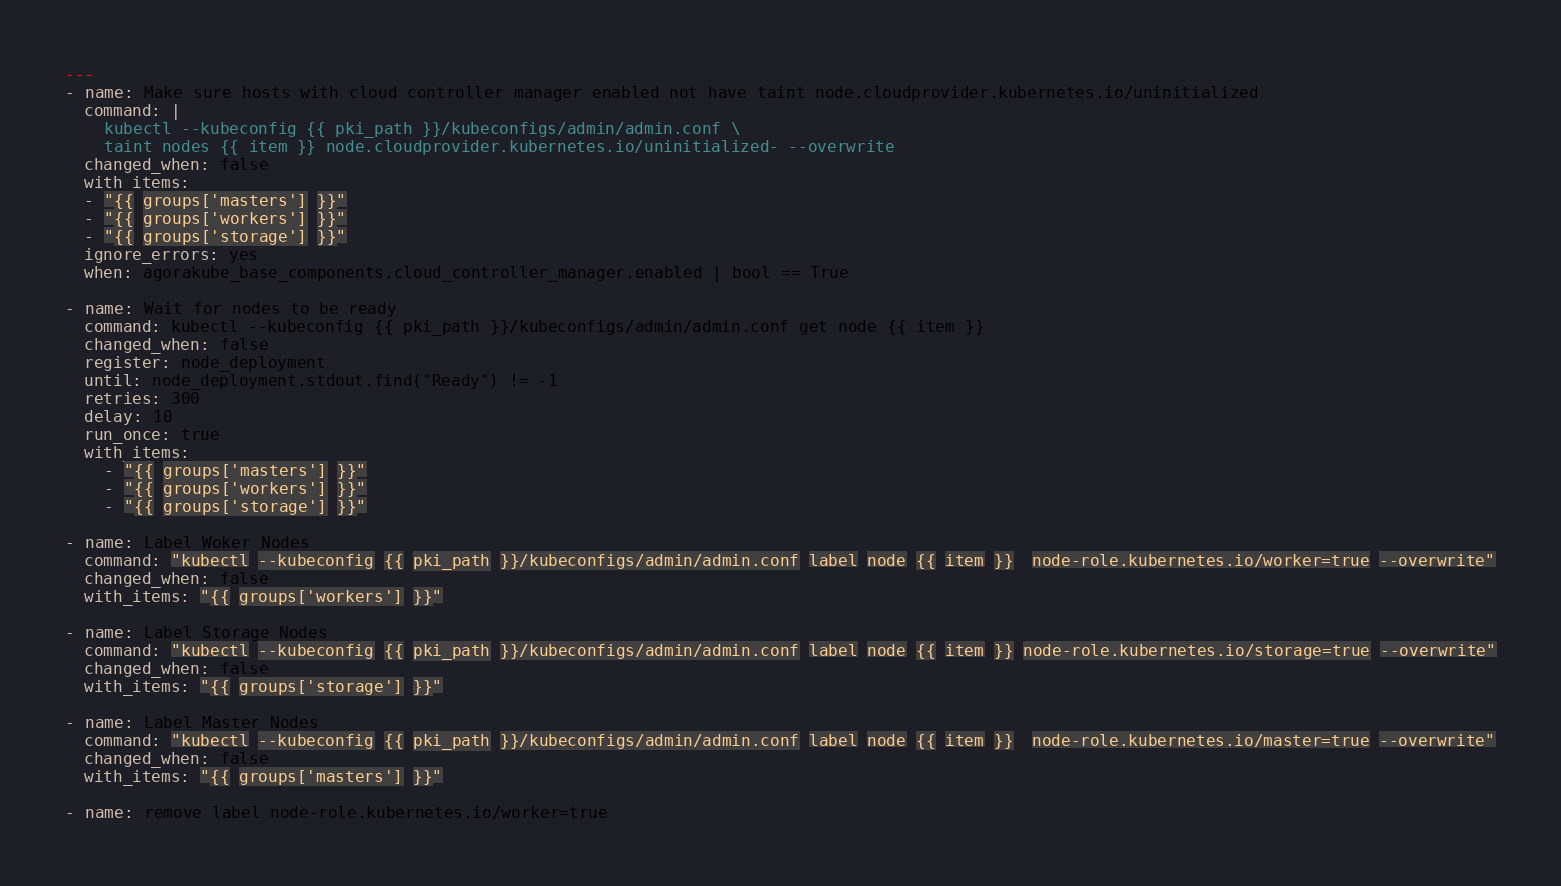<code> <loc_0><loc_0><loc_500><loc_500><_YAML_>---
- name: Make sure hosts with cloud controller manager enabled not have taint node.cloudprovider.kubernetes.io/uninitialized
  command: |
    kubectl --kubeconfig {{ pki_path }}/kubeconfigs/admin/admin.conf \
    taint nodes {{ item }} node.cloudprovider.kubernetes.io/uninitialized- --overwrite
  changed_when: false
  with_items:
  - "{{ groups['masters'] }}"
  - "{{ groups['workers'] }}"
  - "{{ groups['storage'] }}"
  ignore_errors: yes
  when: agorakube_base_components.cloud_controller_manager.enabled | bool == True

- name: Wait for nodes to be ready
  command: kubectl --kubeconfig {{ pki_path }}/kubeconfigs/admin/admin.conf get node {{ item }}
  changed_when: false
  register: node_deployment
  until: node_deployment.stdout.find("Ready") != -1
  retries: 300
  delay: 10
  run_once: true
  with_items:
    - "{{ groups['masters'] }}"
    - "{{ groups['workers'] }}"
    - "{{ groups['storage'] }}"

- name: Label Woker Nodes
  command: "kubectl --kubeconfig {{ pki_path }}/kubeconfigs/admin/admin.conf label node {{ item }}  node-role.kubernetes.io/worker=true --overwrite"
  changed_when: false
  with_items: "{{ groups['workers'] }}"

- name: Label Storage Nodes
  command: "kubectl --kubeconfig {{ pki_path }}/kubeconfigs/admin/admin.conf label node {{ item }} node-role.kubernetes.io/storage=true --overwrite"
  changed_when: false
  with_items: "{{ groups['storage'] }}"

- name: Label Master Nodes
  command: "kubectl --kubeconfig {{ pki_path }}/kubeconfigs/admin/admin.conf label node {{ item }}  node-role.kubernetes.io/master=true --overwrite"
  changed_when: false
  with_items: "{{ groups['masters'] }}"

- name: remove label node-role.kubernetes.io/worker=true</code> 